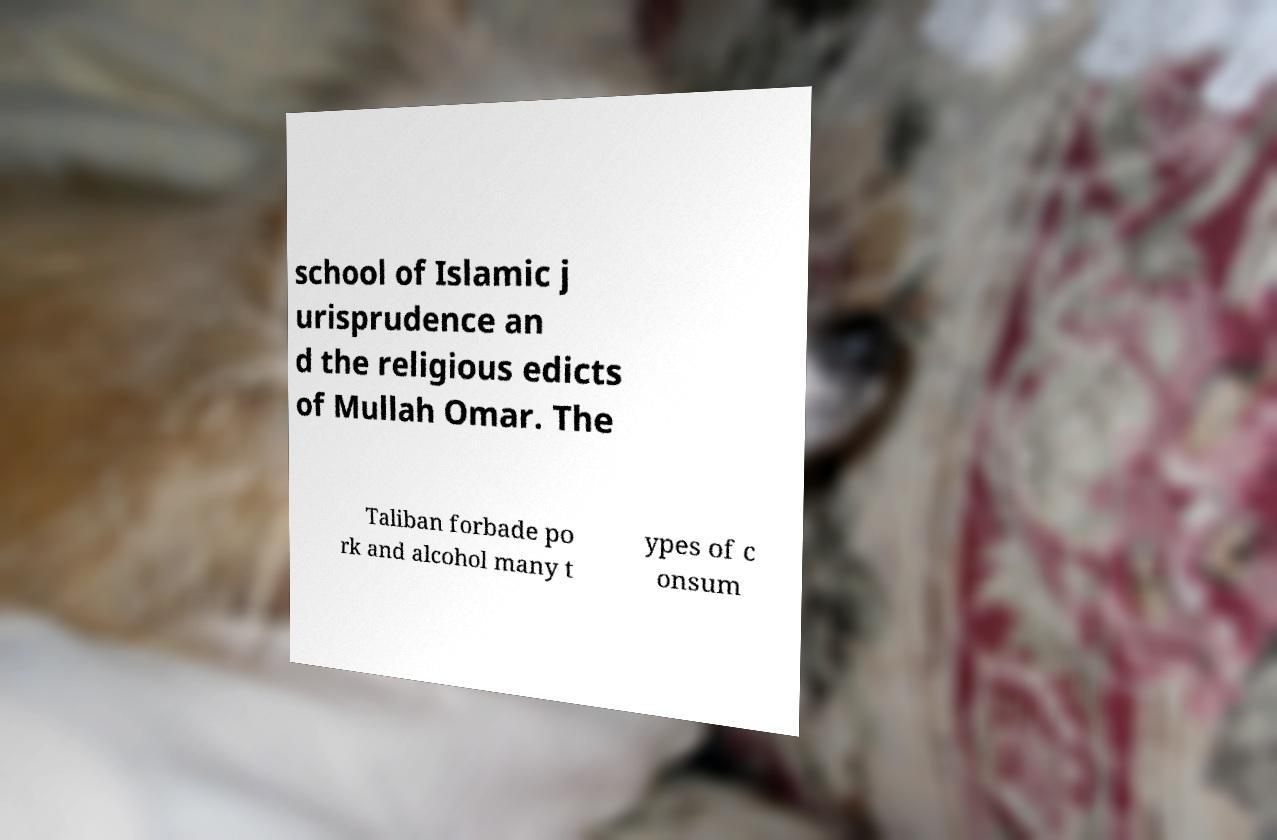Can you read and provide the text displayed in the image?This photo seems to have some interesting text. Can you extract and type it out for me? school of Islamic j urisprudence an d the religious edicts of Mullah Omar. The Taliban forbade po rk and alcohol many t ypes of c onsum 